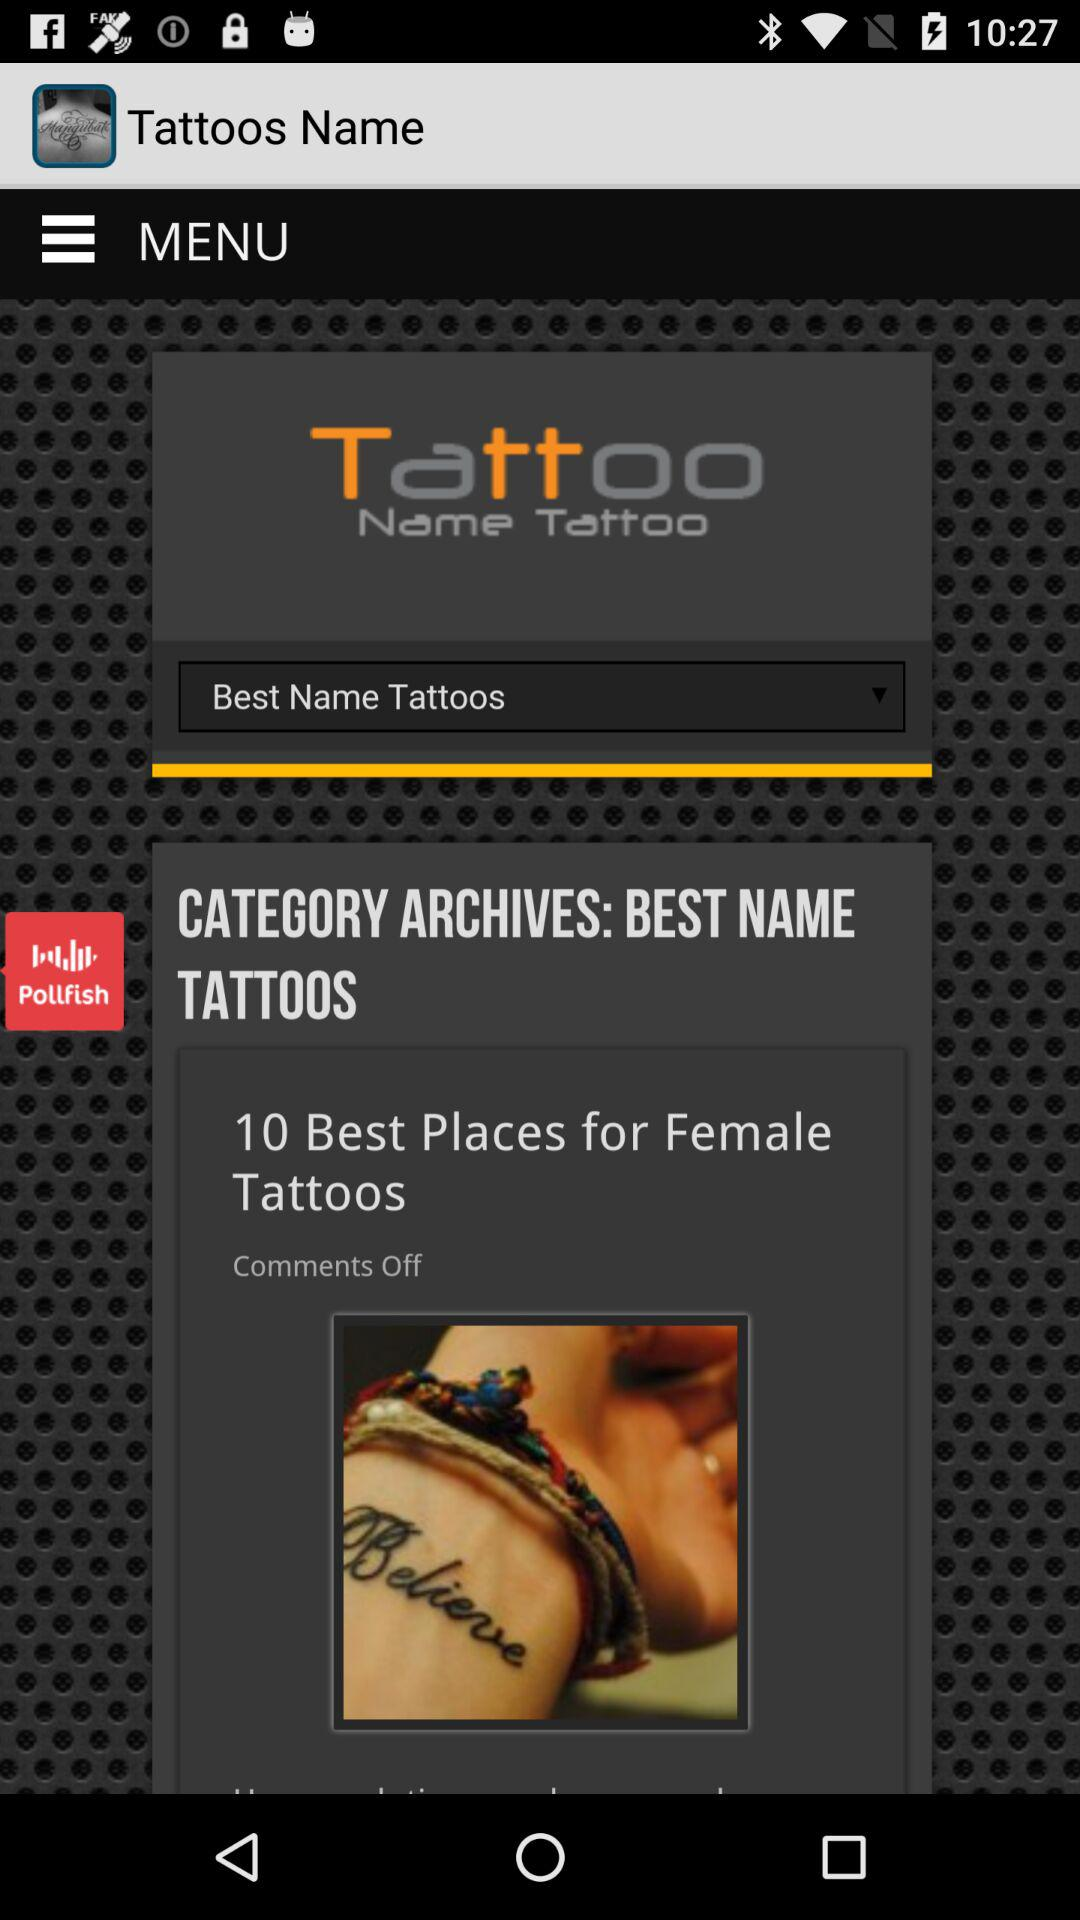What is the application name? The application name is "Tattoos Name". 